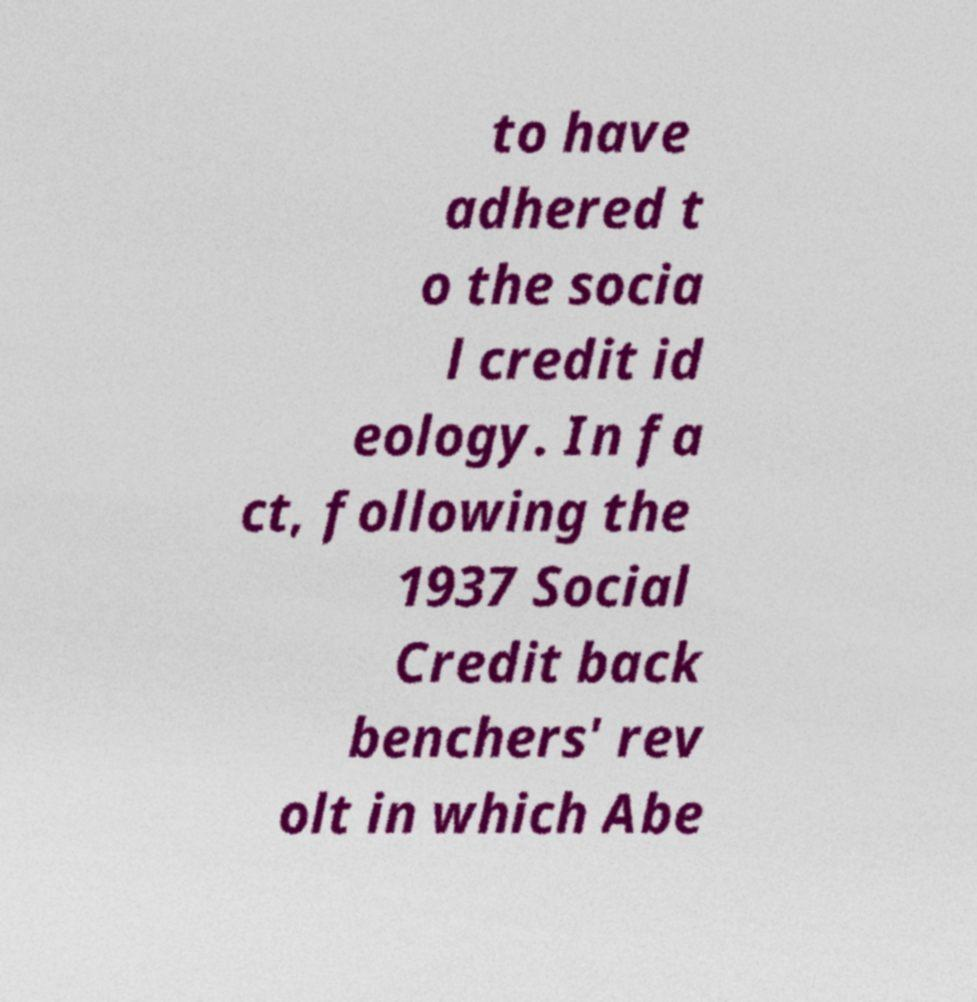Please read and relay the text visible in this image. What does it say? to have adhered t o the socia l credit id eology. In fa ct, following the 1937 Social Credit back benchers' rev olt in which Abe 